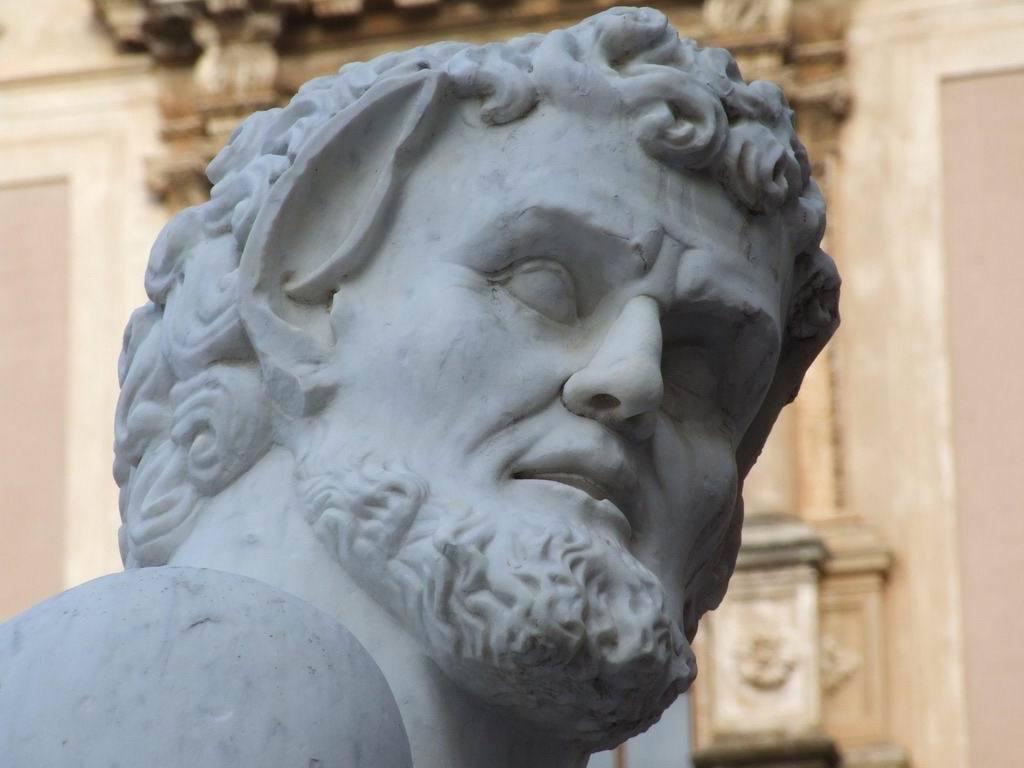How would you summarize this image in a sentence or two? In this image we can see a sculpture of a person. There is a wall behind a sculpture of a person. 